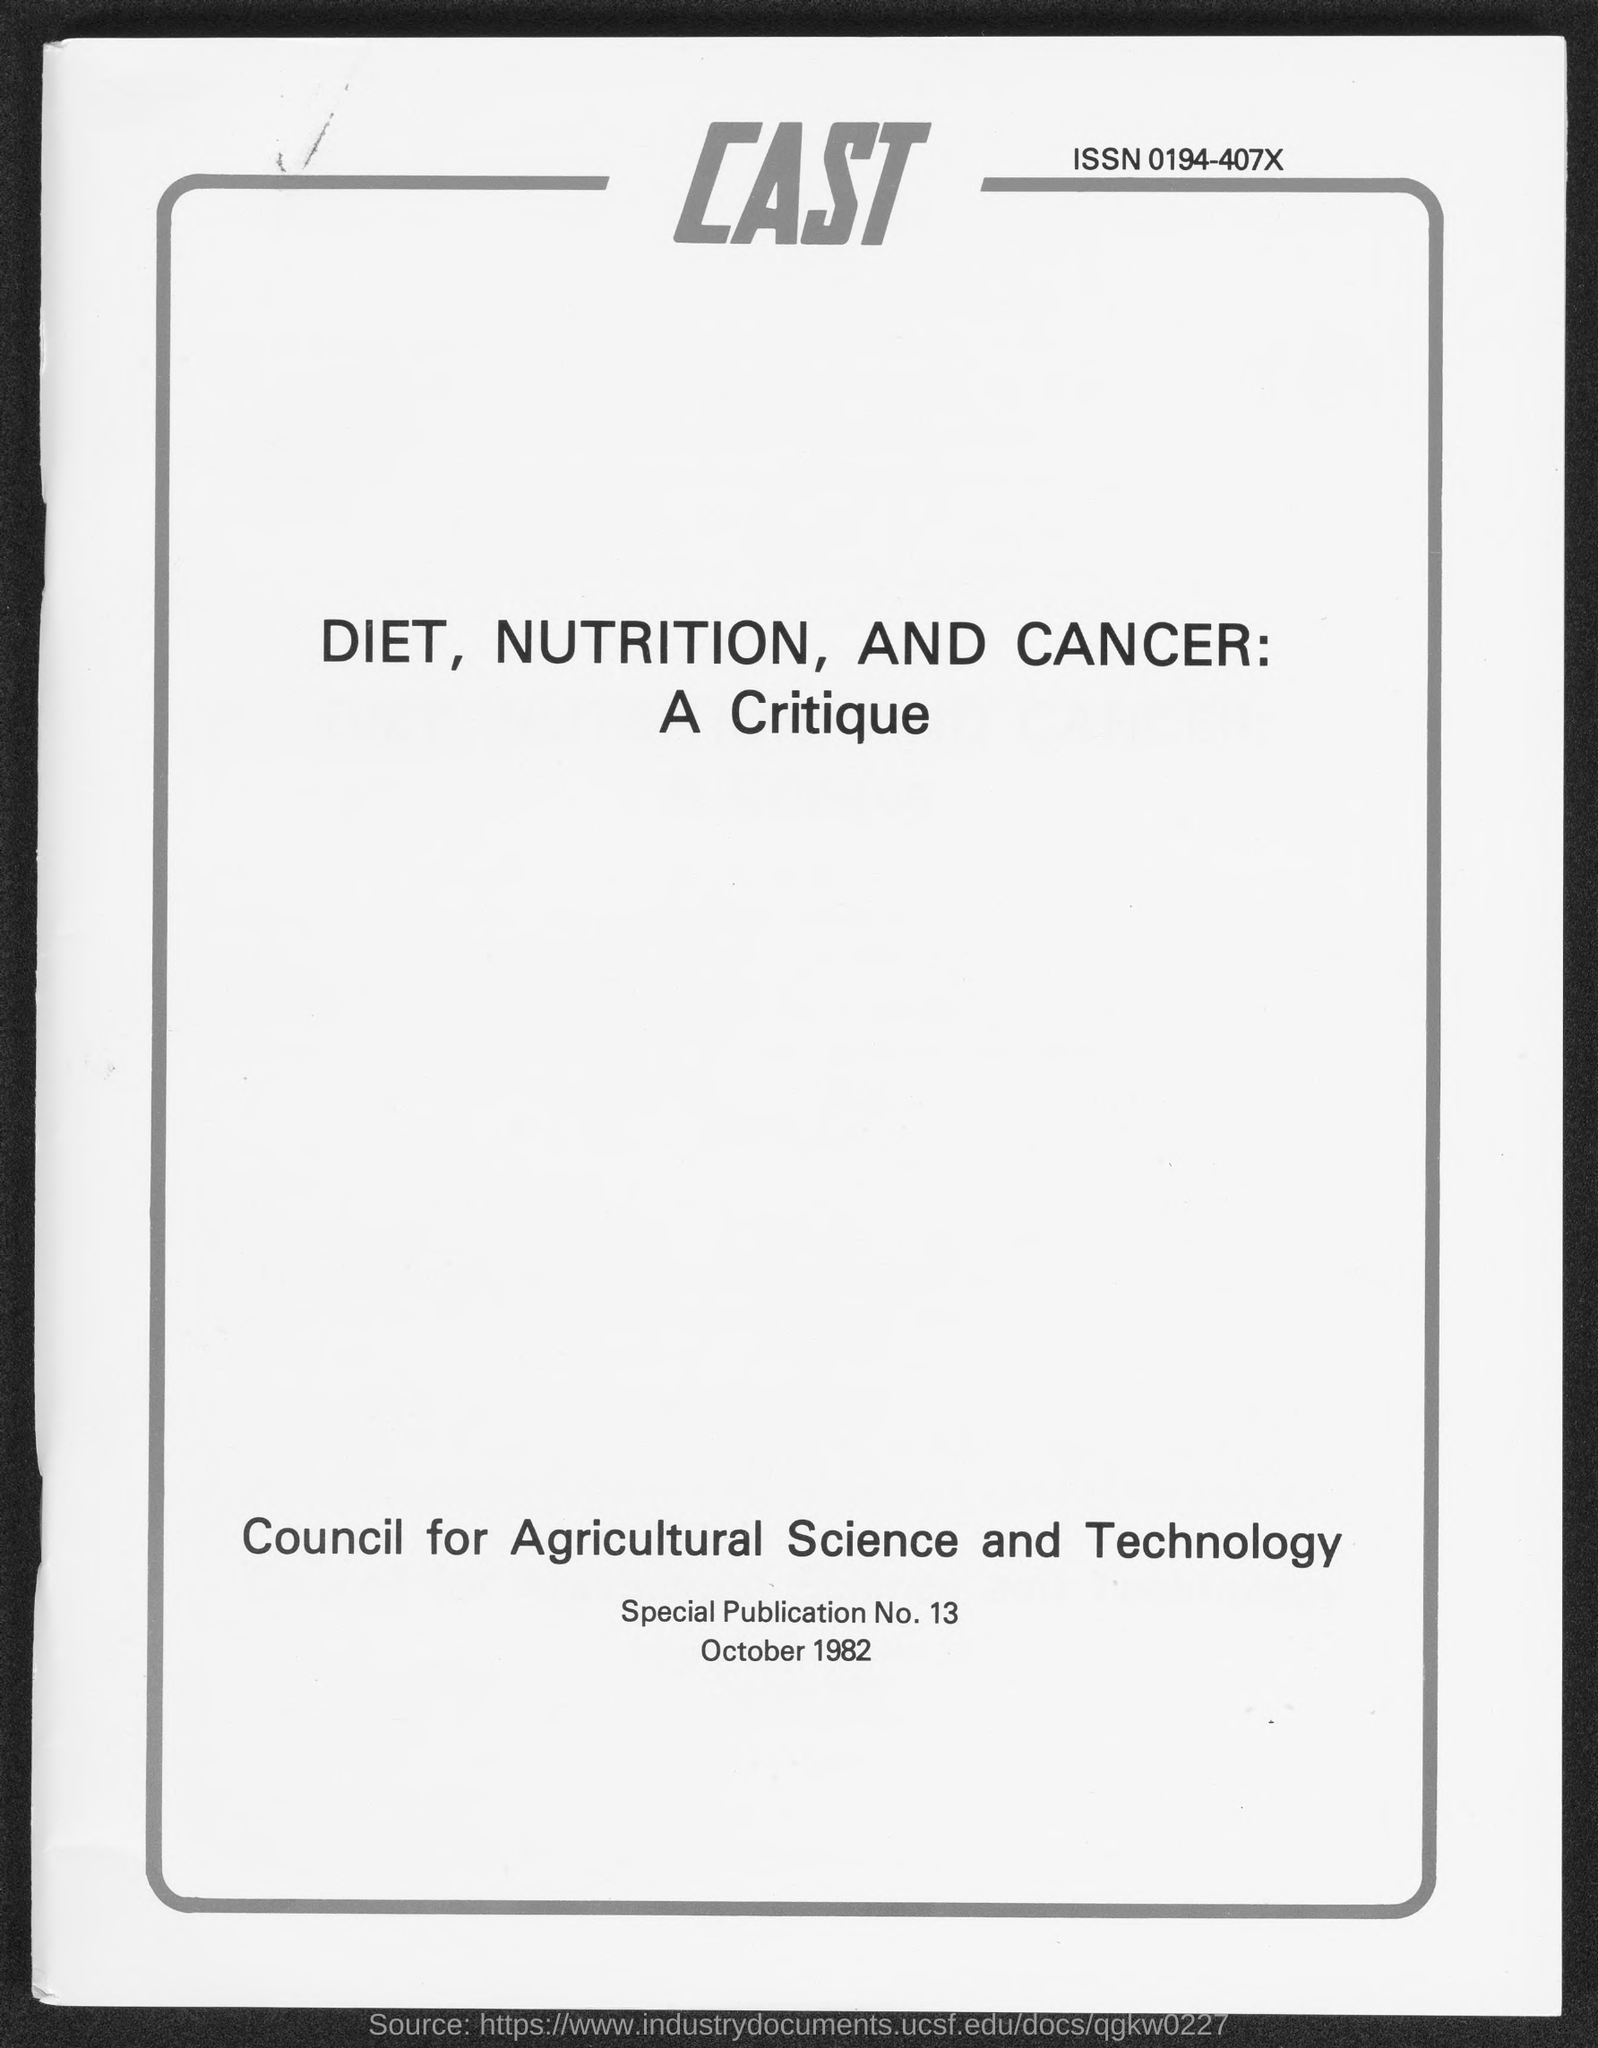Give some essential details in this illustration. What is the Special Publication Number?" is a question that requires an answer. 